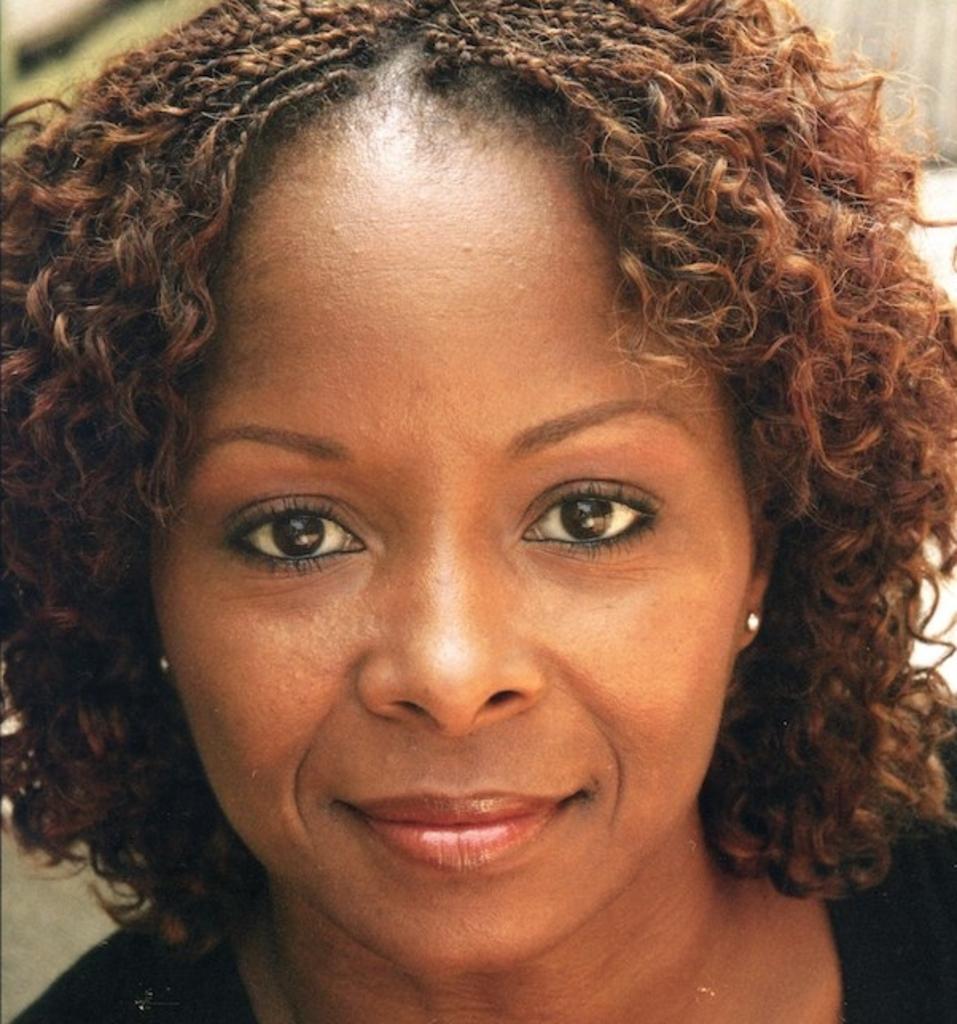How would you summarize this image in a sentence or two? The picture consists of a woman, she is having curly hair and wearing a black t-shirt. The background is not clear. 